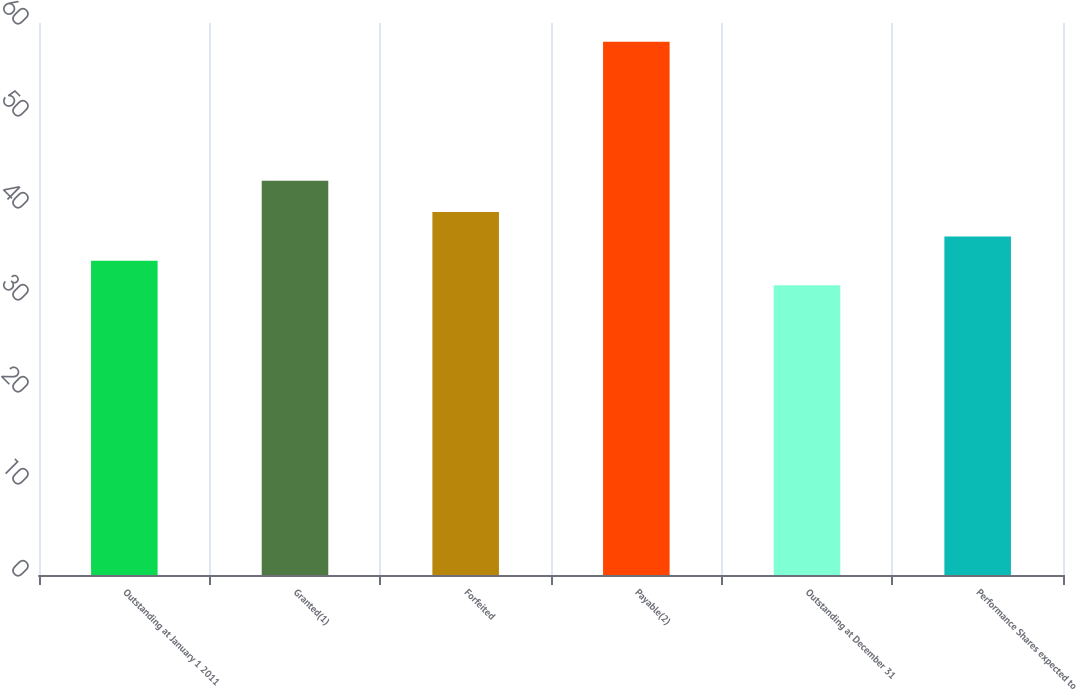<chart> <loc_0><loc_0><loc_500><loc_500><bar_chart><fcel>Outstanding at January 1 2011<fcel>Granted(1)<fcel>Forfeited<fcel>Payable(2)<fcel>Outstanding at December 31<fcel>Performance Shares expected to<nl><fcel>34.15<fcel>42.84<fcel>39.45<fcel>57.95<fcel>31.5<fcel>36.8<nl></chart> 